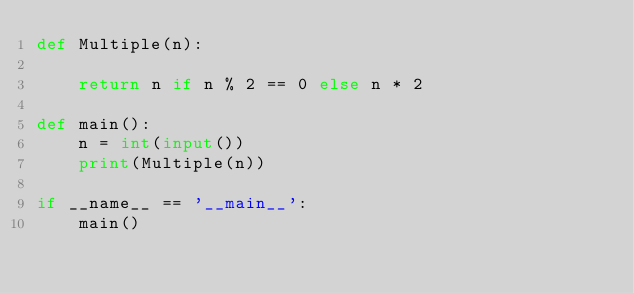Convert code to text. <code><loc_0><loc_0><loc_500><loc_500><_Python_>def Multiple(n):

    return n if n % 2 == 0 else n * 2

def main():
    n = int(input())
    print(Multiple(n))

if __name__ == '__main__':
    main()</code> 